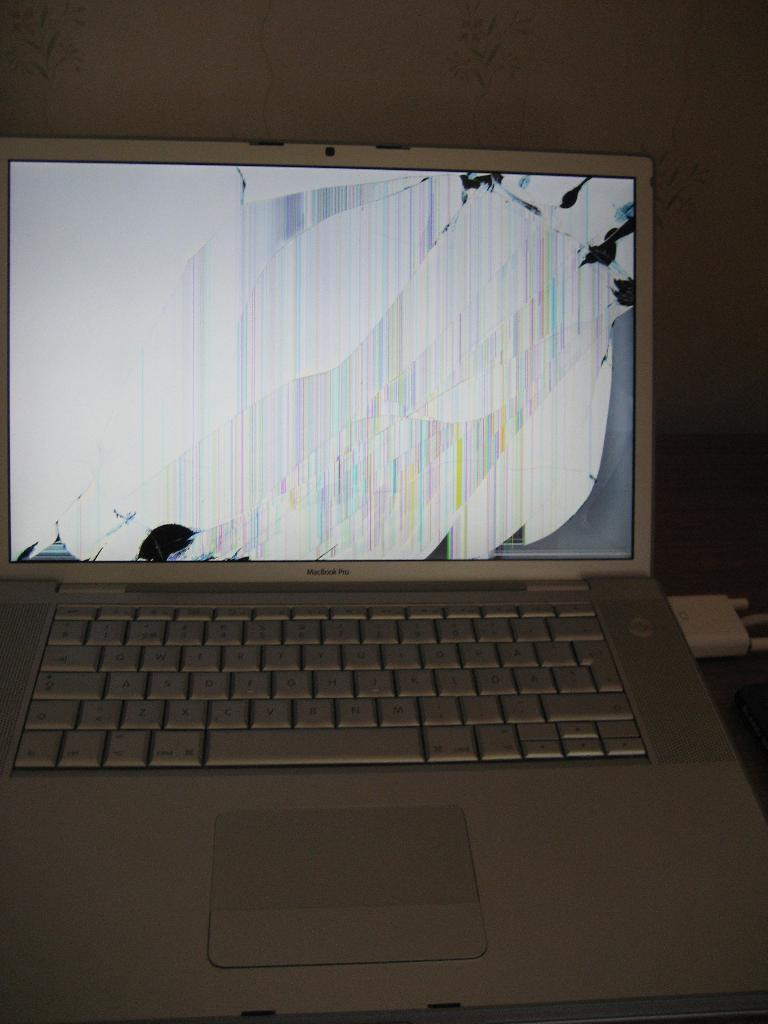Provide a one-sentence caption for the provided image. A macbook pro that has a broken screen. 